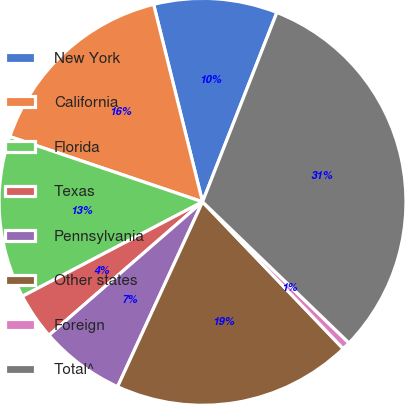Convert chart to OTSL. <chart><loc_0><loc_0><loc_500><loc_500><pie_chart><fcel>New York<fcel>California<fcel>Florida<fcel>Texas<fcel>Pennsylvania<fcel>Other states<fcel>Foreign<fcel>Total^<nl><fcel>9.82%<fcel>15.94%<fcel>12.88%<fcel>3.7%<fcel>6.76%<fcel>19.01%<fcel>0.64%<fcel>31.25%<nl></chart> 